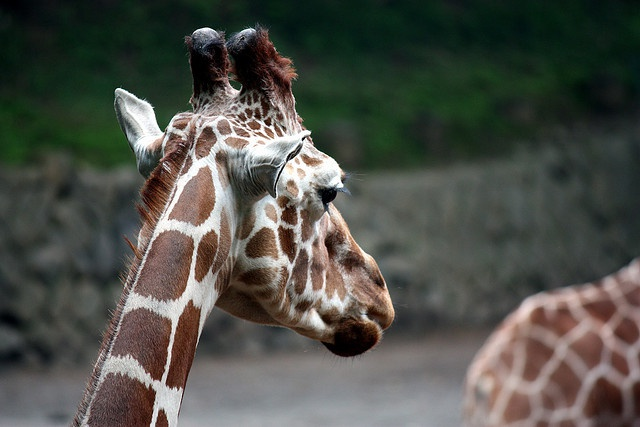Describe the objects in this image and their specific colors. I can see giraffe in black, gray, lightgray, and maroon tones and giraffe in black, darkgray, gray, brown, and maroon tones in this image. 